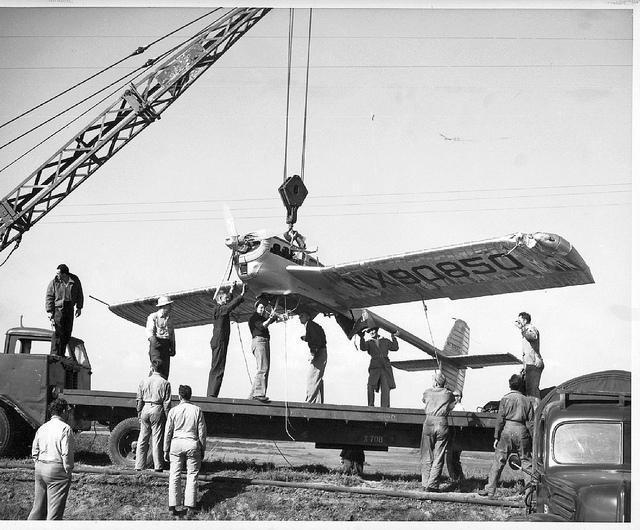How many trucks are there?
Give a very brief answer. 2. How many people are visible?
Give a very brief answer. 6. 